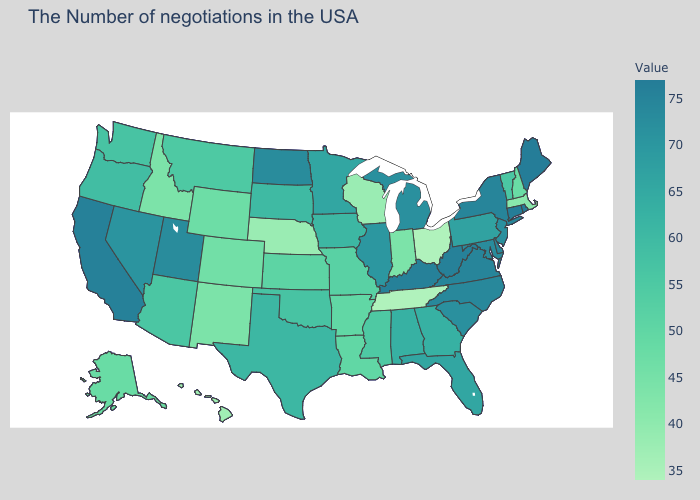Which states have the highest value in the USA?
Keep it brief. Maine, Rhode Island, Connecticut. Is the legend a continuous bar?
Concise answer only. Yes. Among the states that border Maine , which have the highest value?
Keep it brief. New Hampshire. 